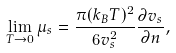Convert formula to latex. <formula><loc_0><loc_0><loc_500><loc_500>\lim _ { T \rightarrow 0 } \mu _ { s } = \frac { \pi ( k _ { B } T ) ^ { 2 } } { 6 v _ { s } ^ { 2 } } \frac { \partial v _ { s } } { \partial n } ,</formula> 